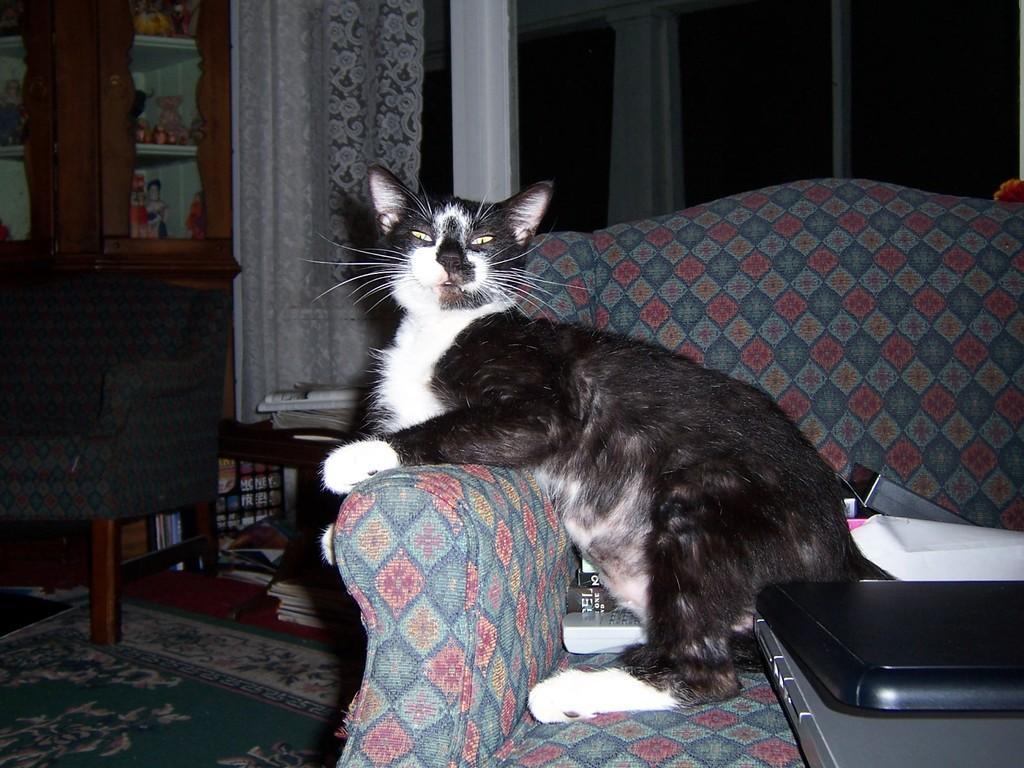Could you give a brief overview of what you see in this image? In the center of the image we can see one roach. On the couch, we can see books, papers, one remote, one box and one cat, which is in black and white color. In front of the couch, we can see one table. On the table, we can see one laptop, which is in black color. In the background there is a wall, carpet, curtain, chair, table, bookshelves, toys and a few other objects. 